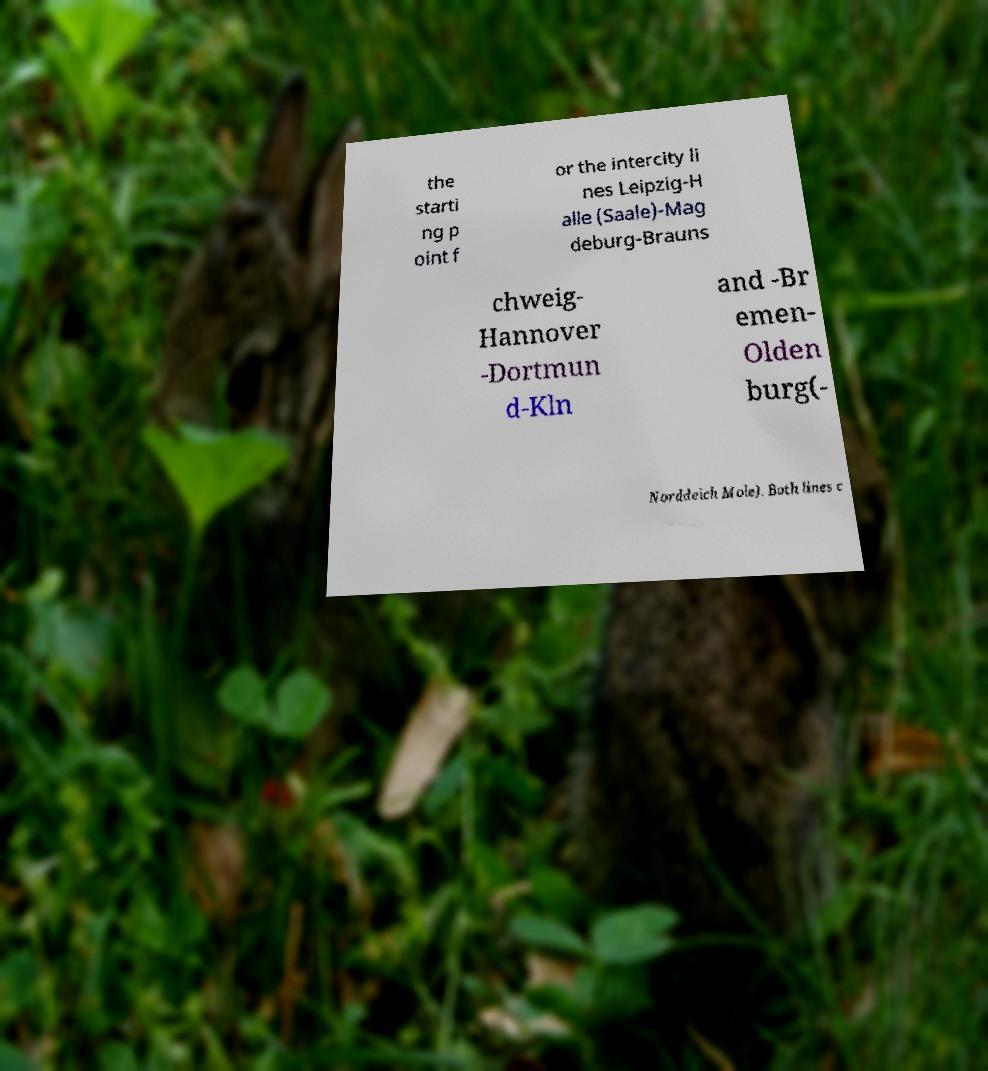I need the written content from this picture converted into text. Can you do that? the starti ng p oint f or the intercity li nes Leipzig-H alle (Saale)-Mag deburg-Brauns chweig- Hannover -Dortmun d-Kln and -Br emen- Olden burg(- Norddeich Mole). Both lines c 